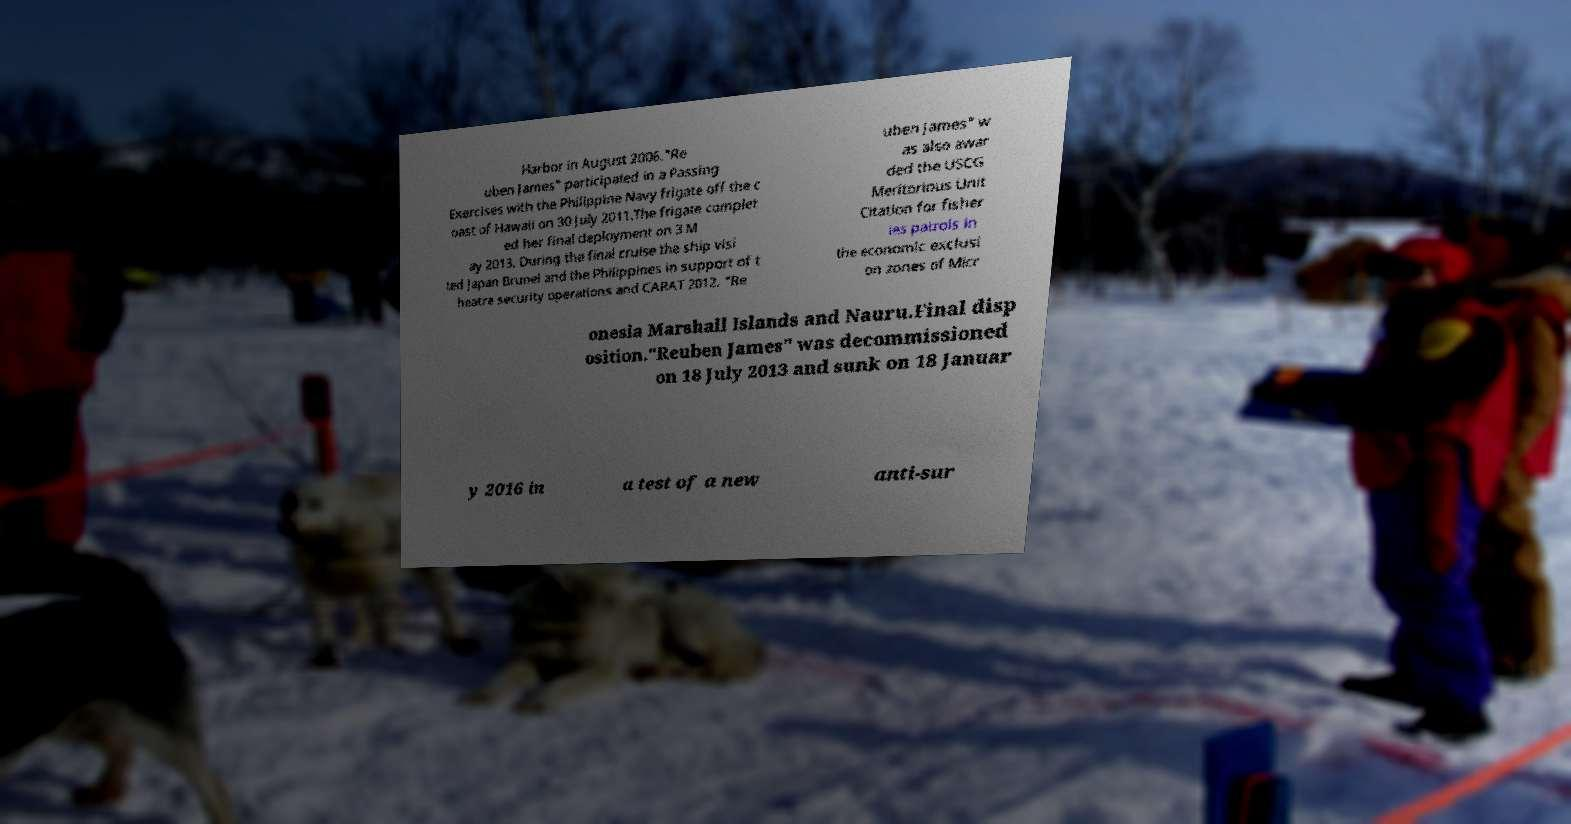Can you read and provide the text displayed in the image?This photo seems to have some interesting text. Can you extract and type it out for me? Harbor in August 2006."Re uben James" participated in a Passing Exercises with the Philippine Navy frigate off the c oast of Hawaii on 30 July 2011.The frigate complet ed her final deployment on 3 M ay 2013. During the final cruise the ship visi ted Japan Brunei and the Philippines in support of t heatre security operations and CARAT 2012. "Re uben James" w as also awar ded the USCG Meritorious Unit Citation for fisher ies patrols in the economic exclusi on zones of Micr onesia Marshall Islands and Nauru.Final disp osition."Reuben James" was decommissioned on 18 July 2013 and sunk on 18 Januar y 2016 in a test of a new anti-sur 